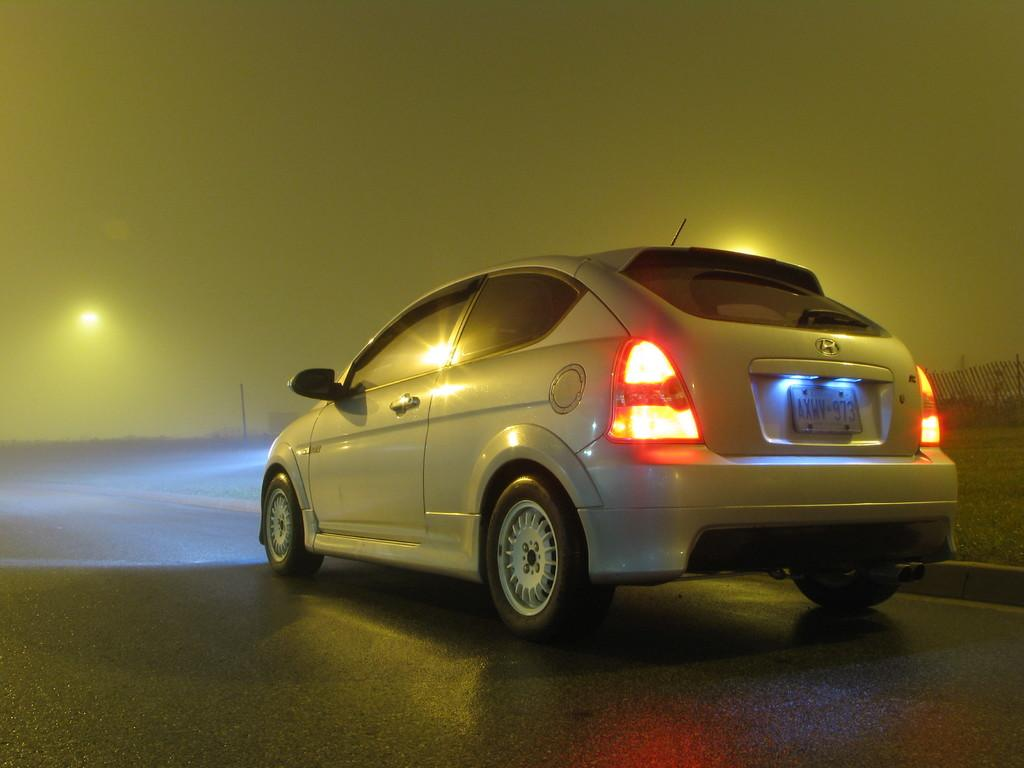<image>
Write a terse but informative summary of the picture. a little car with an AXWY license plate 